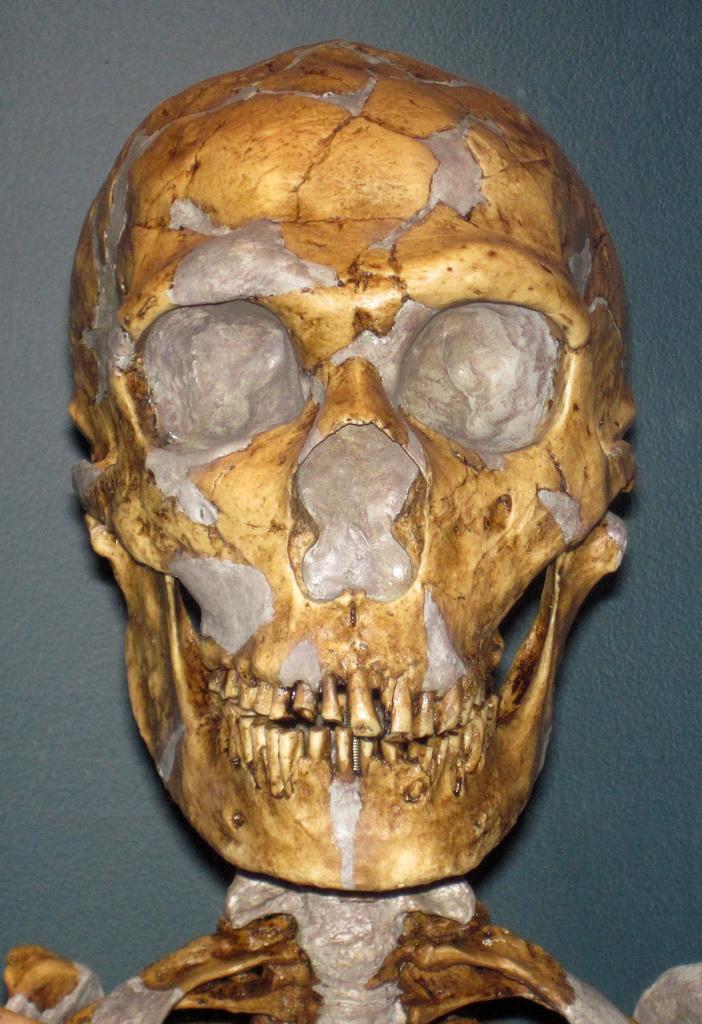Could you give a brief overview of what you see in this image? In this picture there is a skeleton which is in gold and silver color. At the back there is a wall. 